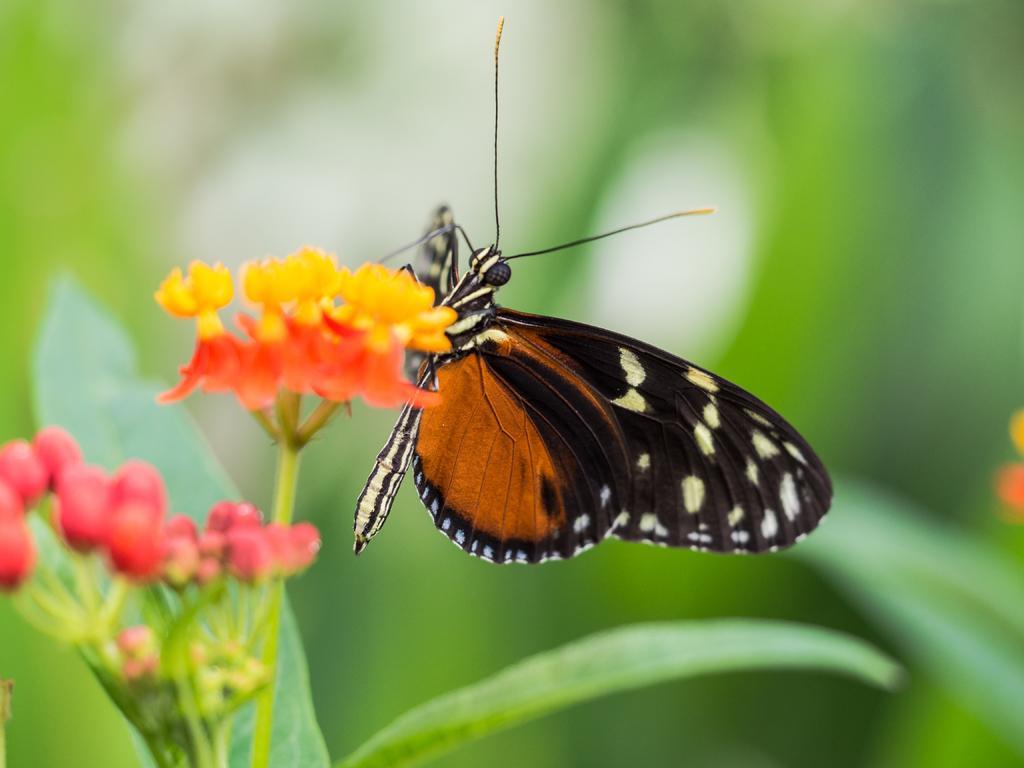Describe this image in one or two sentences. In this image I can see few green leaves, number of flowers and a brown and black colour butterfly. I can also see green colour in the background and I can see this image is blurry in the background. 